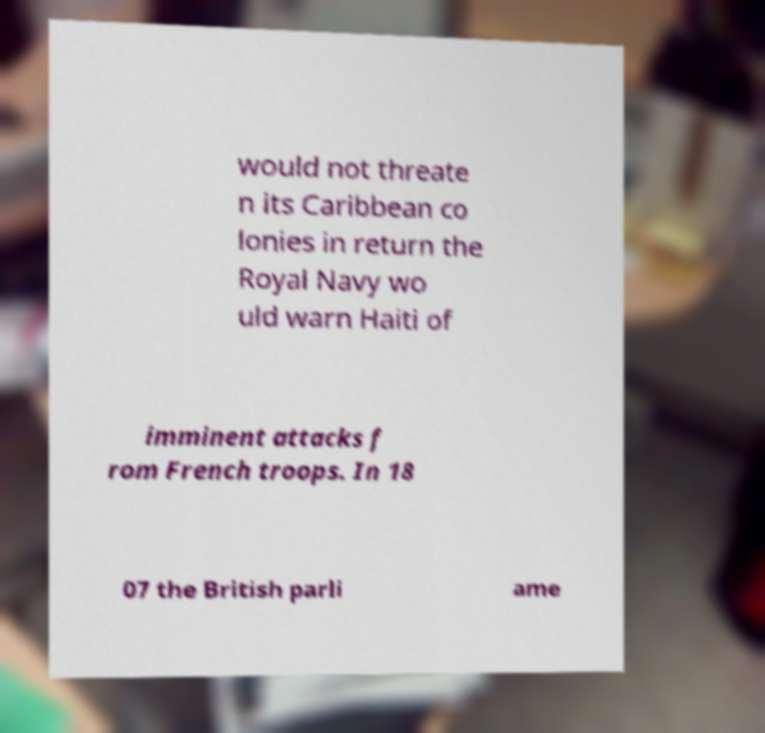Please identify and transcribe the text found in this image. would not threate n its Caribbean co lonies in return the Royal Navy wo uld warn Haiti of imminent attacks f rom French troops. In 18 07 the British parli ame 